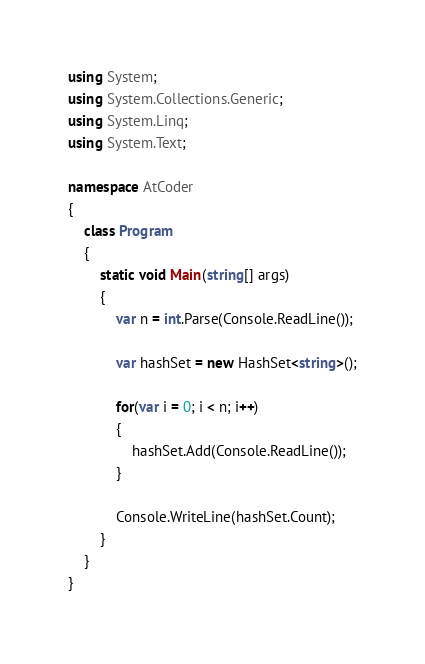<code> <loc_0><loc_0><loc_500><loc_500><_C#_>using System;
using System.Collections.Generic;
using System.Linq;
using System.Text;

namespace AtCoder
{
	class Program
	{
		static void Main(string[] args)
		{
			var n = int.Parse(Console.ReadLine());

			var hashSet = new HashSet<string>();

			for(var i = 0; i < n; i++)
			{
				hashSet.Add(Console.ReadLine());
			}

			Console.WriteLine(hashSet.Count);
		}
	}
}
</code> 